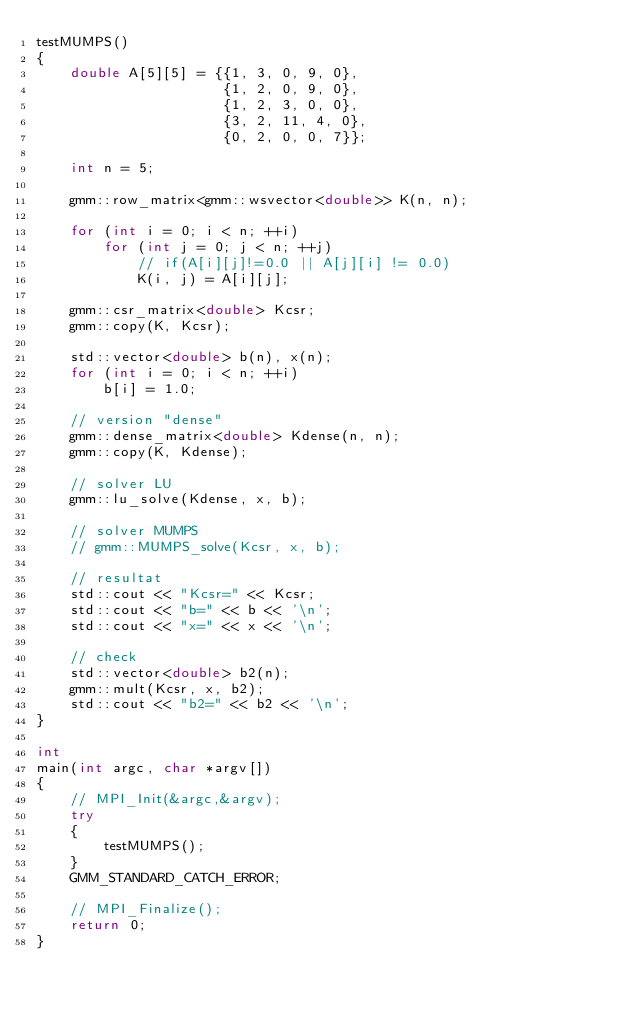<code> <loc_0><loc_0><loc_500><loc_500><_C++_>testMUMPS()
{
    double A[5][5] = {{1, 3, 0, 9, 0},
                      {1, 2, 0, 9, 0},
                      {1, 2, 3, 0, 0},
                      {3, 2, 11, 4, 0},
                      {0, 2, 0, 0, 7}};

    int n = 5;

    gmm::row_matrix<gmm::wsvector<double>> K(n, n);

    for (int i = 0; i < n; ++i)
        for (int j = 0; j < n; ++j)
            // if(A[i][j]!=0.0 || A[j][i] != 0.0)
            K(i, j) = A[i][j];

    gmm::csr_matrix<double> Kcsr;
    gmm::copy(K, Kcsr);

    std::vector<double> b(n), x(n);
    for (int i = 0; i < n; ++i)
        b[i] = 1.0;

    // version "dense"
    gmm::dense_matrix<double> Kdense(n, n);
    gmm::copy(K, Kdense);

    // solver LU
    gmm::lu_solve(Kdense, x, b);

    // solver MUMPS
    // gmm::MUMPS_solve(Kcsr, x, b);

    // resultat
    std::cout << "Kcsr=" << Kcsr;
    std::cout << "b=" << b << '\n';
    std::cout << "x=" << x << '\n';

    // check
    std::vector<double> b2(n);
    gmm::mult(Kcsr, x, b2);
    std::cout << "b2=" << b2 << '\n';
}

int
main(int argc, char *argv[])
{
    // MPI_Init(&argc,&argv);
    try
    {
        testMUMPS();
    }
    GMM_STANDARD_CATCH_ERROR;

    // MPI_Finalize();
    return 0;
}
</code> 